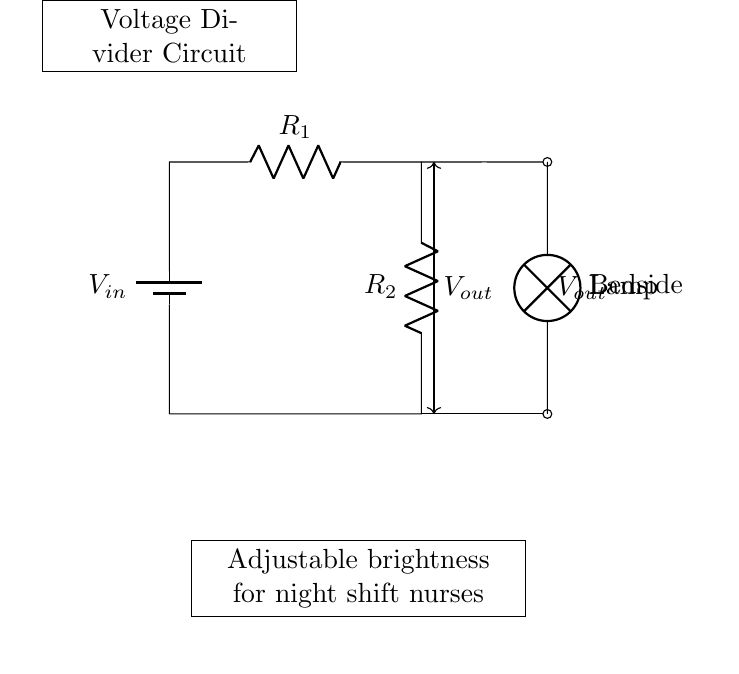What is the purpose of this circuit? The circuit is designed as a voltage divider to adjust the brightness of a bedside lamp. The resistors divide the input voltage to provide a lower output voltage suitable for dimming.
Answer: Voltage divider for lamp brightness adjustment What type of components are used in this circuit? The circuit includes two resistors, a battery, and a lamp as the load. These components work together to create the voltage divider functionality with adjusted brightness.
Answer: Resistors, battery, lamp What is the function of R1 and R2? R1 and R2 are resistors that work together in the voltage divider to reduce the input voltage, allowing for different levels of brightness in the lamp depending on the resistance values.
Answer: They divide the voltage What is the significance of the output voltage? The output voltage, Vout, is crucial as it represents the voltage that powers the bedside lamp. By adjusting R1 and R2, nurses can control the brightness of the lamp to suit their needs during night shifts.
Answer: Controls lamp brightness How can R1 and R2 be adjusted in this circuit? R1 and R2 can be adjusted by changing their resistance values, which can be done by using potentiometers or selecting different resistors. This adjustment directly affects Vout and hence the lamp's brightness.
Answer: By changing resistance values What happens if R1 is increased while R2 remains constant? If R1 is increased while R2 remains constant, the output voltage Vout will decrease, which would result in a dimmer lamp. This is because a higher resistance in R1 reduces the voltage drop across R2.
Answer: Vout decreases, lamp dims 